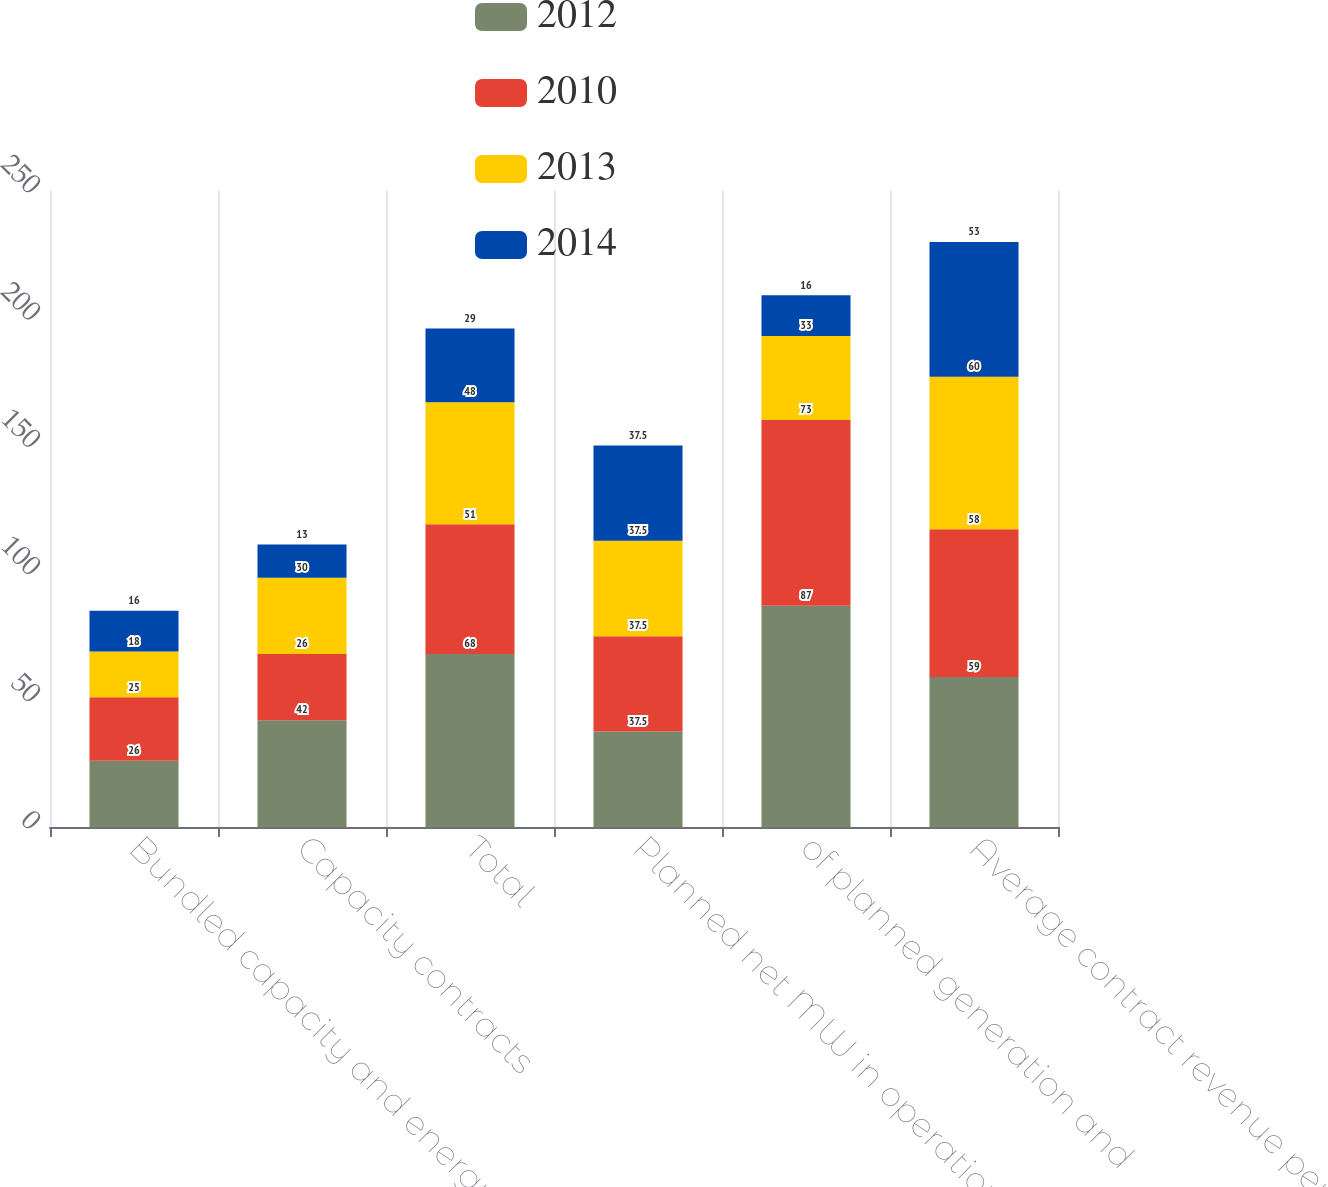Convert chart to OTSL. <chart><loc_0><loc_0><loc_500><loc_500><stacked_bar_chart><ecel><fcel>Bundled capacity and energy<fcel>Capacity contracts<fcel>Total<fcel>Planned net MW in operation<fcel>of planned generation and<fcel>Average contract revenue per<nl><fcel>2012<fcel>26<fcel>42<fcel>68<fcel>37.5<fcel>87<fcel>59<nl><fcel>2010<fcel>25<fcel>26<fcel>51<fcel>37.5<fcel>73<fcel>58<nl><fcel>2013<fcel>18<fcel>30<fcel>48<fcel>37.5<fcel>33<fcel>60<nl><fcel>2014<fcel>16<fcel>13<fcel>29<fcel>37.5<fcel>16<fcel>53<nl></chart> 